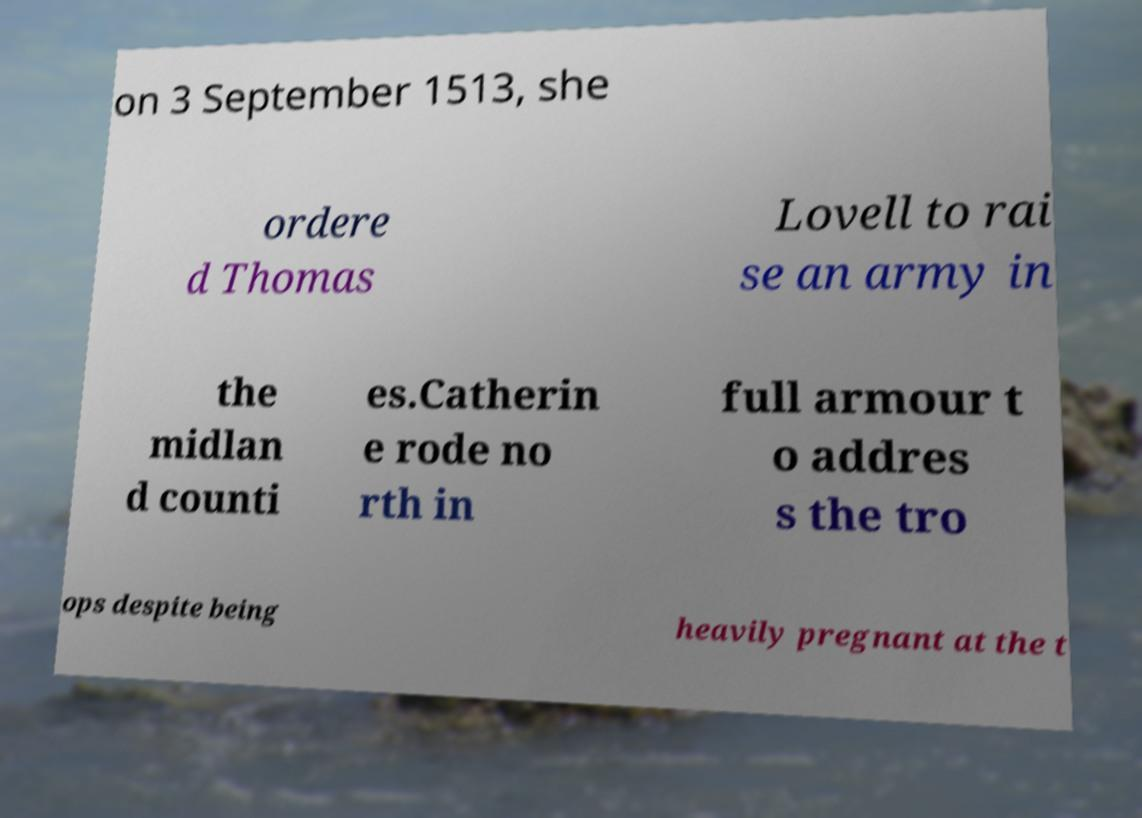Please read and relay the text visible in this image. What does it say? on 3 September 1513, she ordere d Thomas Lovell to rai se an army in the midlan d counti es.Catherin e rode no rth in full armour t o addres s the tro ops despite being heavily pregnant at the t 